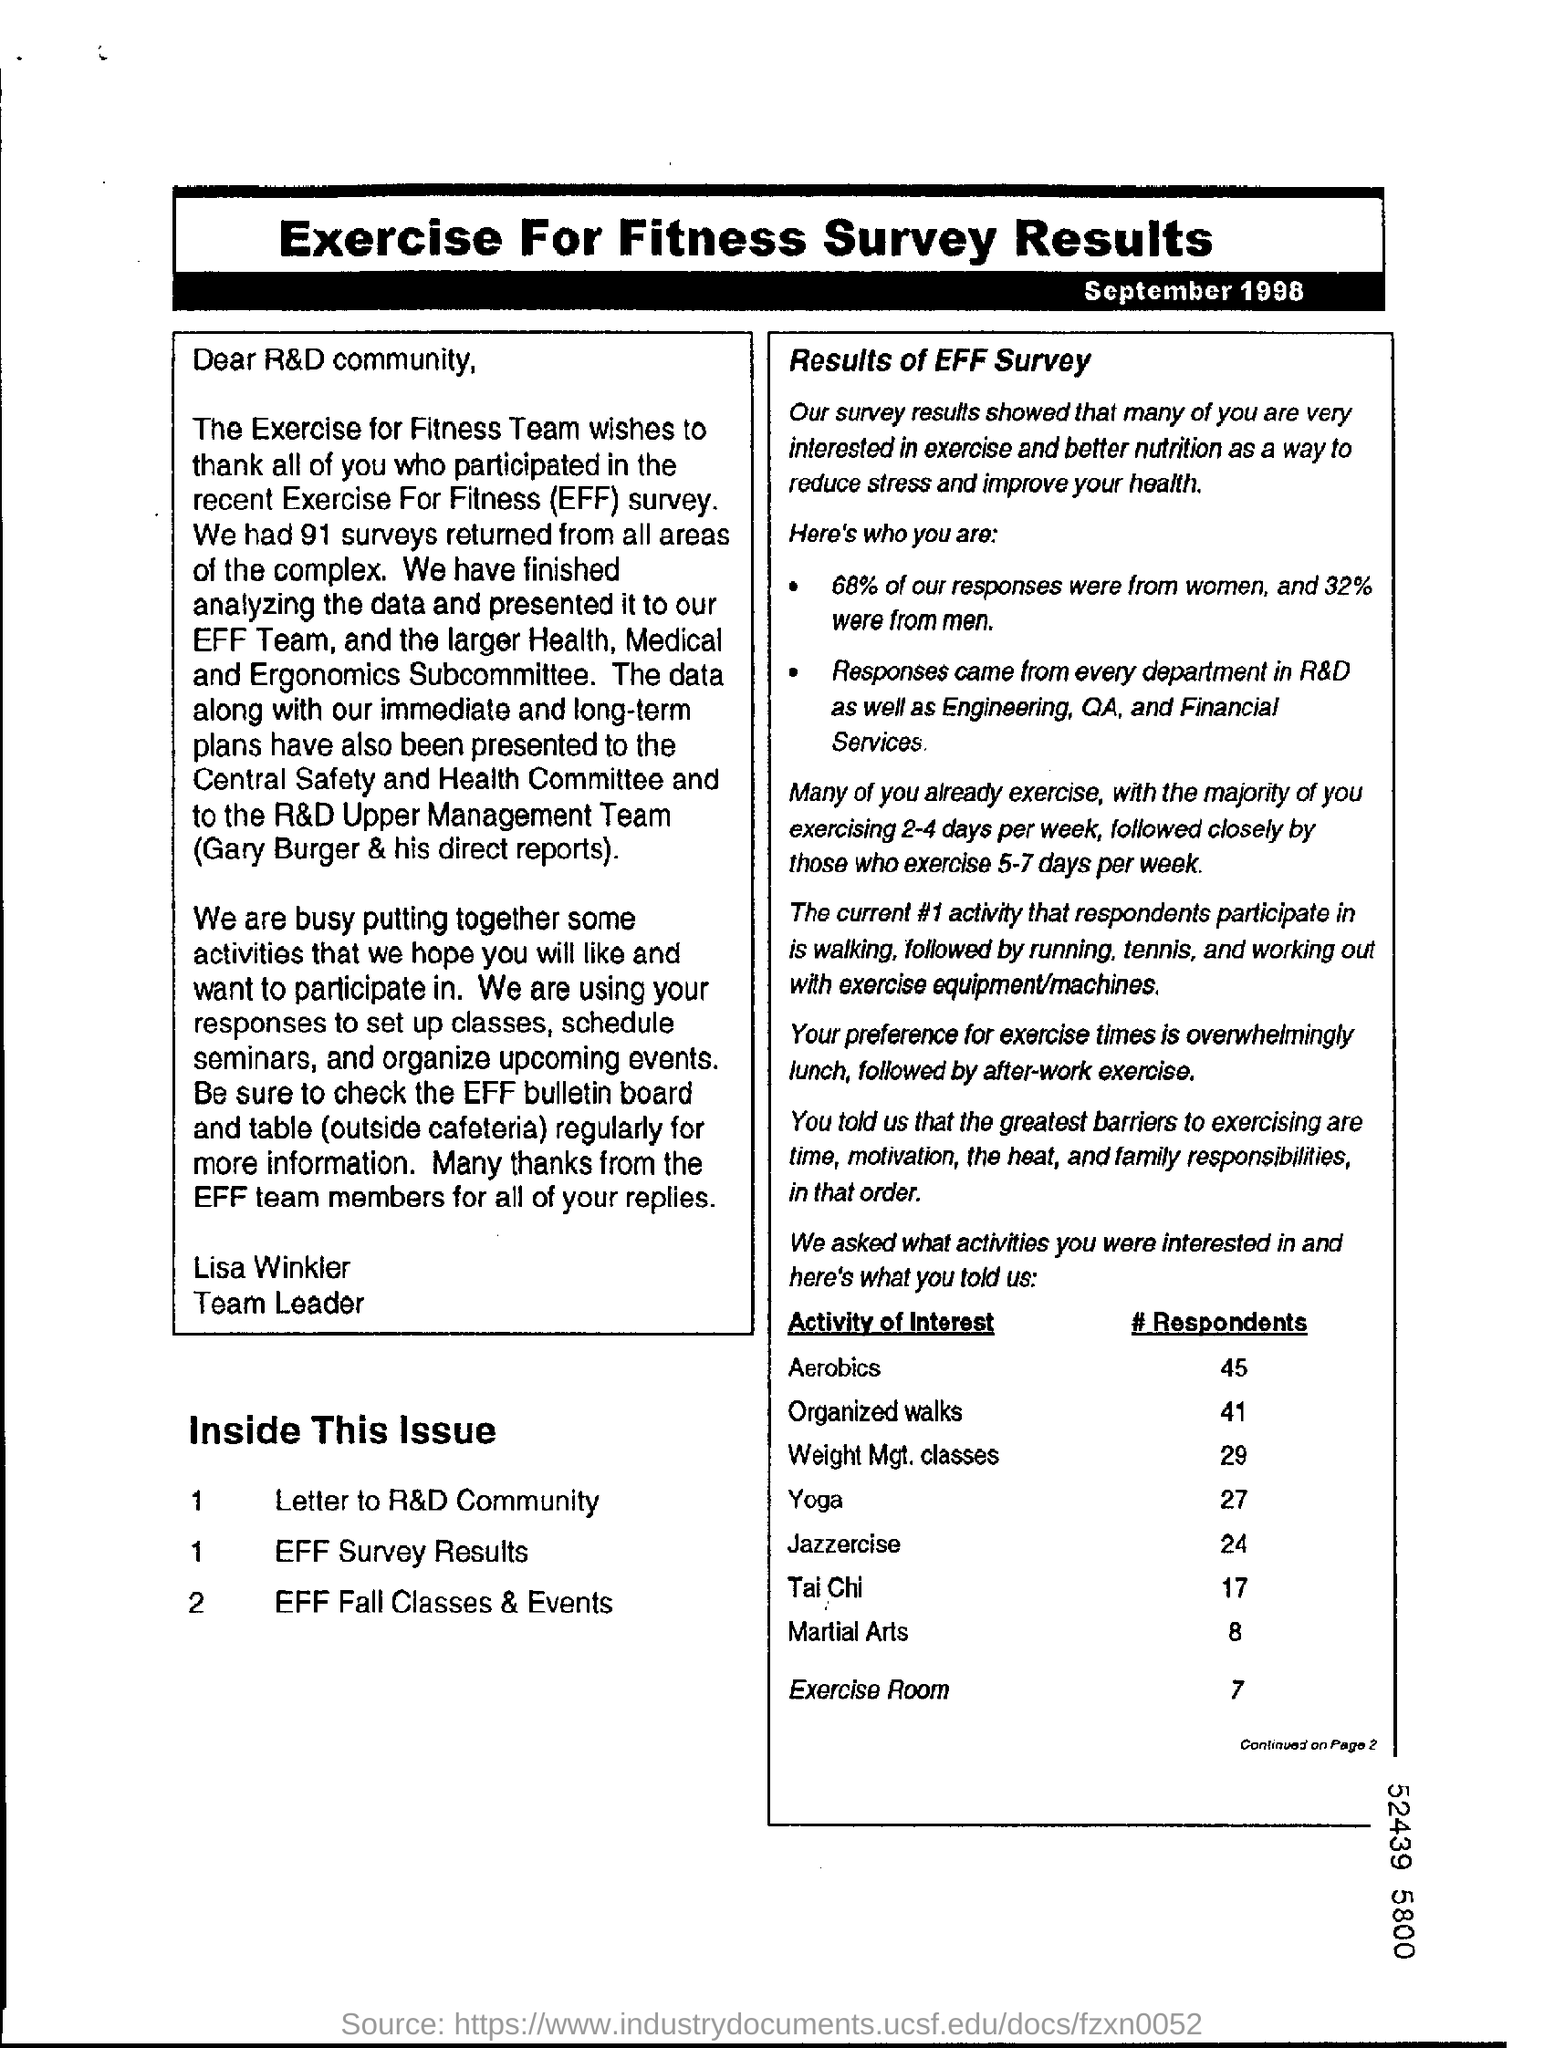Draw attention to some important aspects in this diagram. According to the response received, 68% of women have expressed their views. According to the data collected, 32% of the responses received were from men. 